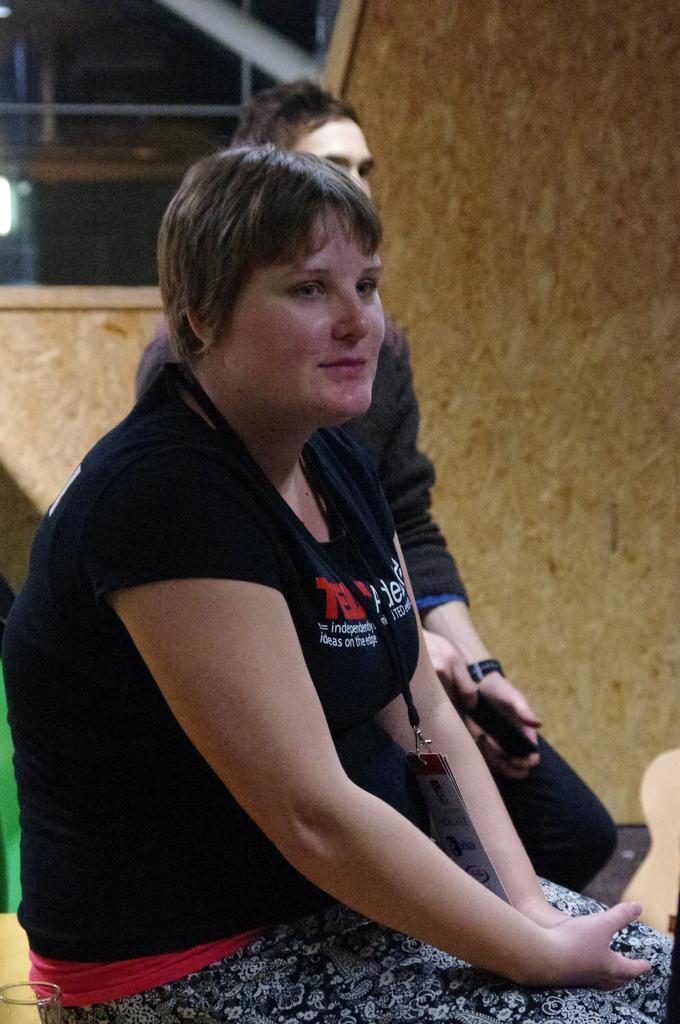Please provide a concise description of this image. In this image I can see two persons and background I can see the wall and light. 